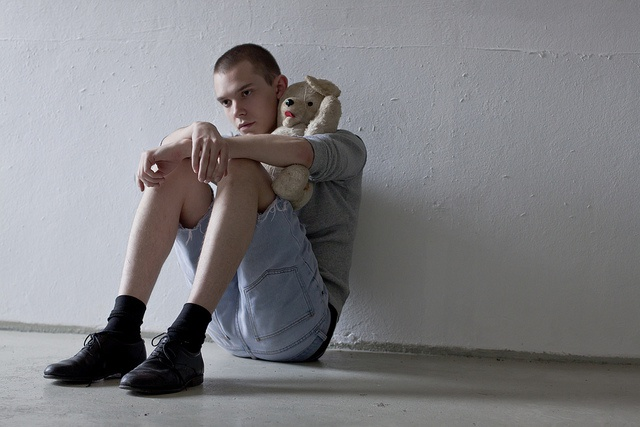Describe the objects in this image and their specific colors. I can see people in lightgray, black, gray, and maroon tones and teddy bear in lightgray, gray, black, and darkgray tones in this image. 